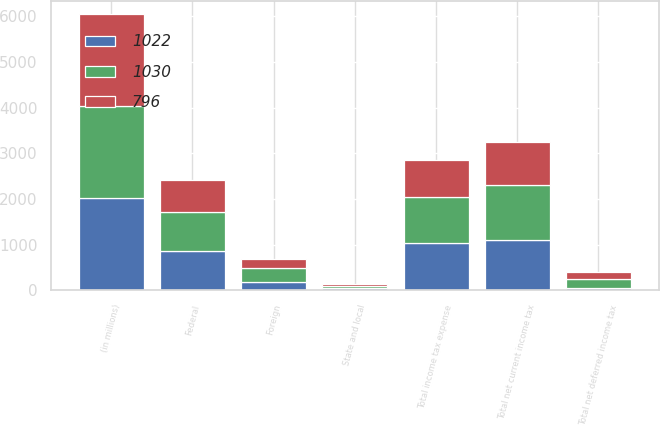Convert chart to OTSL. <chart><loc_0><loc_0><loc_500><loc_500><stacked_bar_chart><ecel><fcel>(in millions)<fcel>Federal<fcel>State and local<fcel>Foreign<fcel>Total net current income tax<fcel>Total net deferred income tax<fcel>Total income tax expense<nl><fcel>1030<fcel>2013<fcel>869<fcel>39<fcel>307<fcel>1215<fcel>193<fcel>1022<nl><fcel>1022<fcel>2012<fcel>856<fcel>49<fcel>186<fcel>1091<fcel>61<fcel>1030<nl><fcel>796<fcel>2011<fcel>693<fcel>54<fcel>186<fcel>933<fcel>137<fcel>796<nl></chart> 